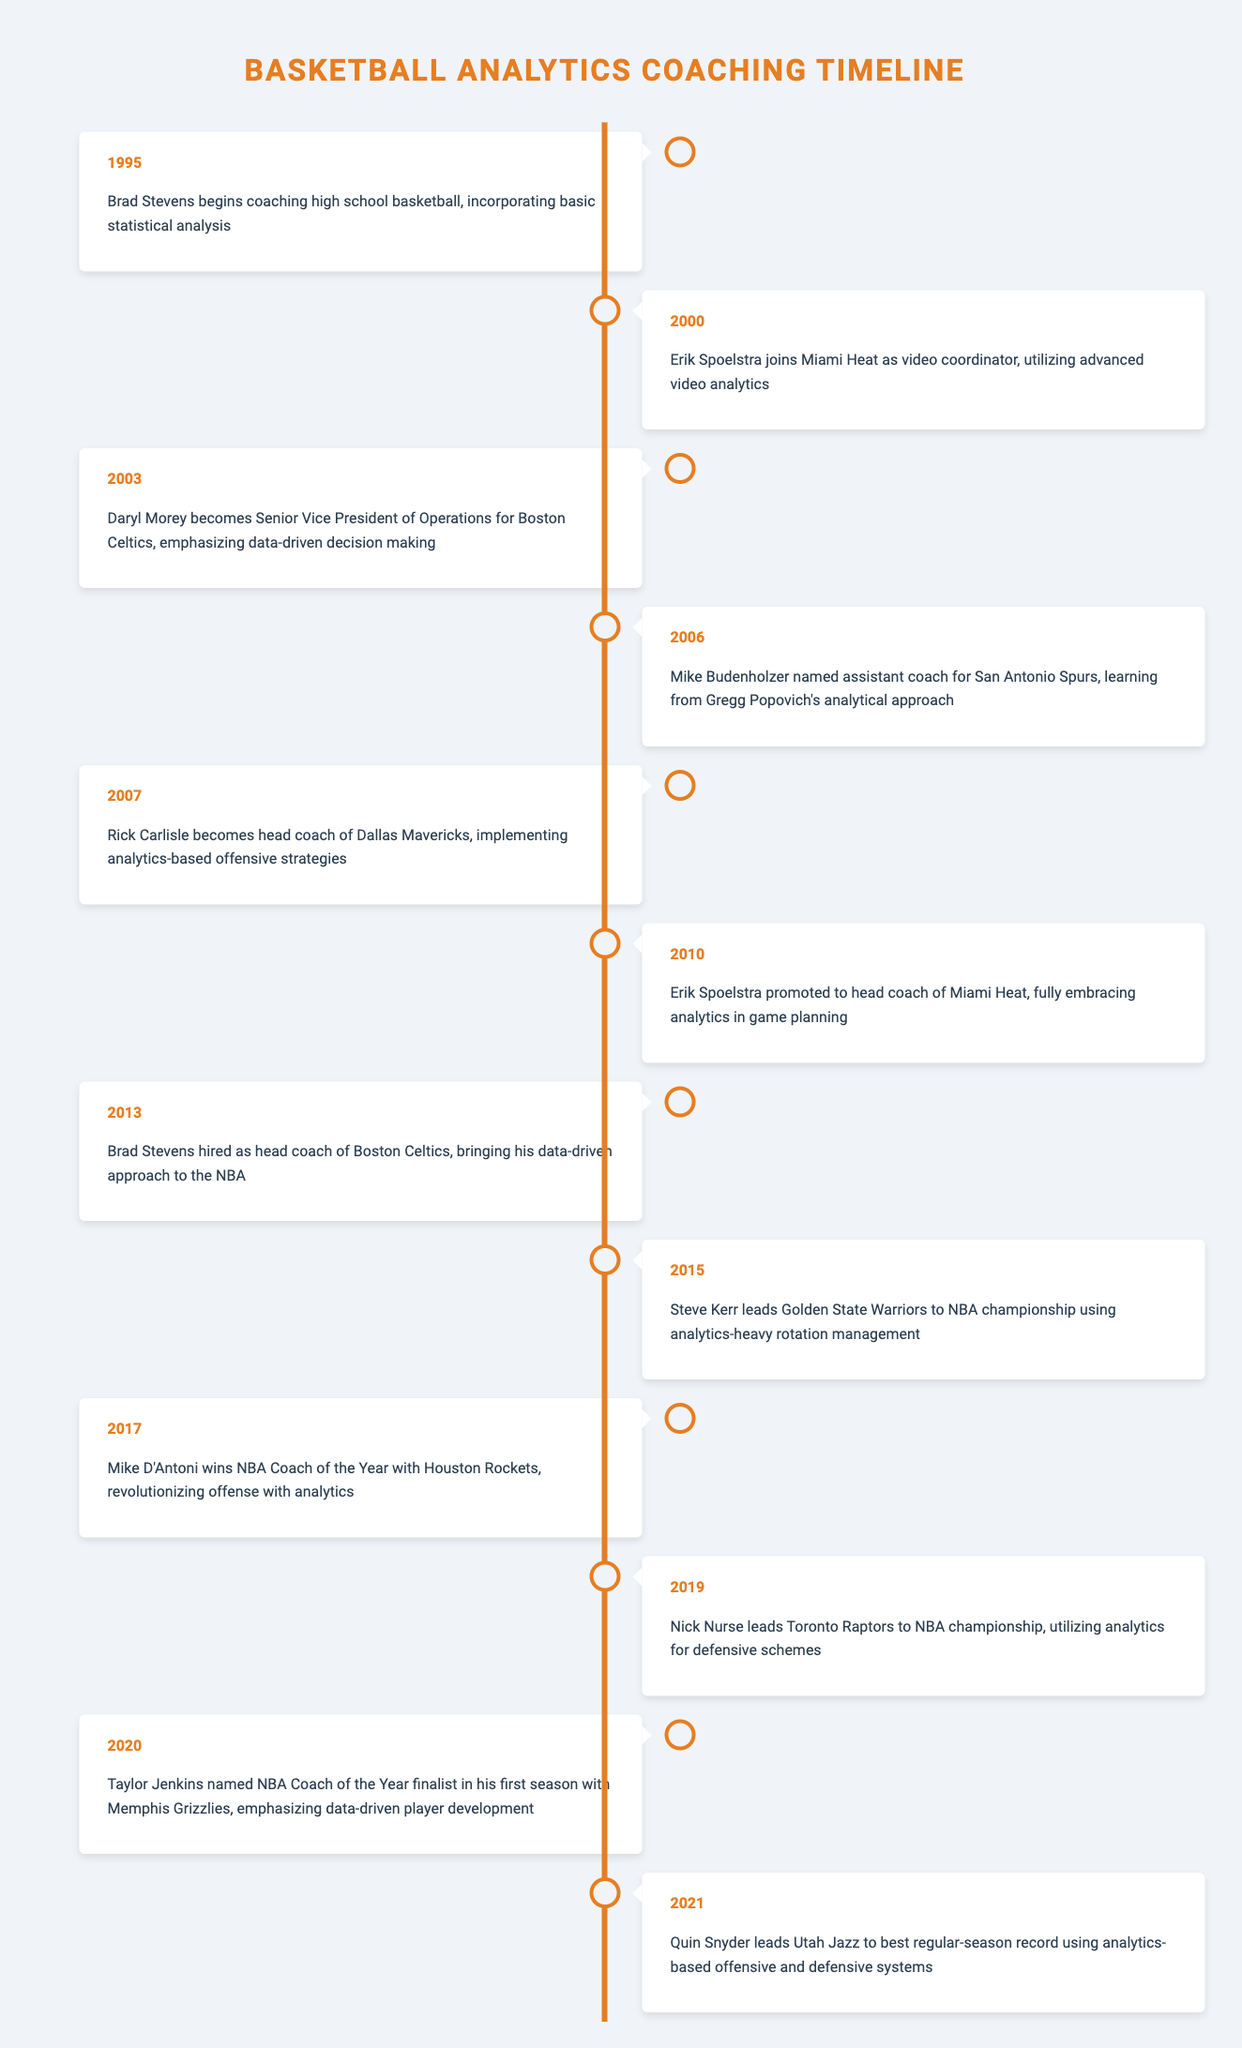What year did Brad Stevens start coaching high school basketball? Brad Stevens began his coaching career in high school basketball in 1995, as indicated in the timeline.
Answer: 1995 Which coach was promoted to head coach of the Miami Heat in 2010? The timeline shows that Erik Spoelstra was promoted to head coach of the Miami Heat in 2010.
Answer: Erik Spoelstra Did Daryl Morey emphasize data-driven decision-making with the Boston Celtics? Based on the data from 2003, Daryl Morey emphasized data-driven decision making when he became Senior Vice President of Operations for the Boston Celtics.
Answer: Yes What is the chronological order of the coaches mentioned from 2000 to 2013? Between 2000 and 2013, the events listed are: Erik Spoelstra joining the Miami Heat in 2000, Daryl Morey's appointment in 2003, Mike Budenholzer's role in 2006, Rick Carlisle's hiring in 2007, and Brad Stevens becoming head coach of the Celtics in 2013. This indicates a series of gradual advancements in analytical coaching.
Answer: Erik Spoelstra, Daryl Morey, Mike Budenholzer, Rick Carlisle, Brad Stevens How many NBA championships were won by teams led by coaches utilizing analytics, as listed in the timeline? The timeline indicates NBA championships were won by Steve Kerr in 2015 and Nick Nurse in 2019, totaling two championships.
Answer: 2 Which coach is noted for revolutionizing offense with analytics in 2017? According to the timeline, Mike D'Antoni won NBA Coach of the Year in 2017 for revolutionizing offense with analytics with the Houston Rockets.
Answer: Mike D'Antoni What is the average year when the head coach events took place from 2010 to 2021? The events in question are from 2010 (Erik Spoelstra), 2013 (Brad Stevens), 2015 (Steve Kerr), 2017 (Mike D'Antoni), 2019 (Nick Nurse), and 2021 (Quin Snyder). The years add up to 2015 and there are 6 data points, so the average year is 2015/6 = approximately 2015.
Answer: 2015 Is there any coach in the timeline who was noted for using advanced video analytics? Yes, Erik Spoelstra, who joined the Miami Heat in 2000 as a video coordinator, is noted for utilizing advanced video analytics in his role.
Answer: Yes What role did Mike Budenholzer have in 2006, and what did he learn from Gregg Popovich? In 2006, Mike Budenholzer was named assistant coach for the San Antonio Spurs. During this time, he learned from Gregg Popovich's analytical approach to coaching.
Answer: Assistant coach, learned analytical approach 